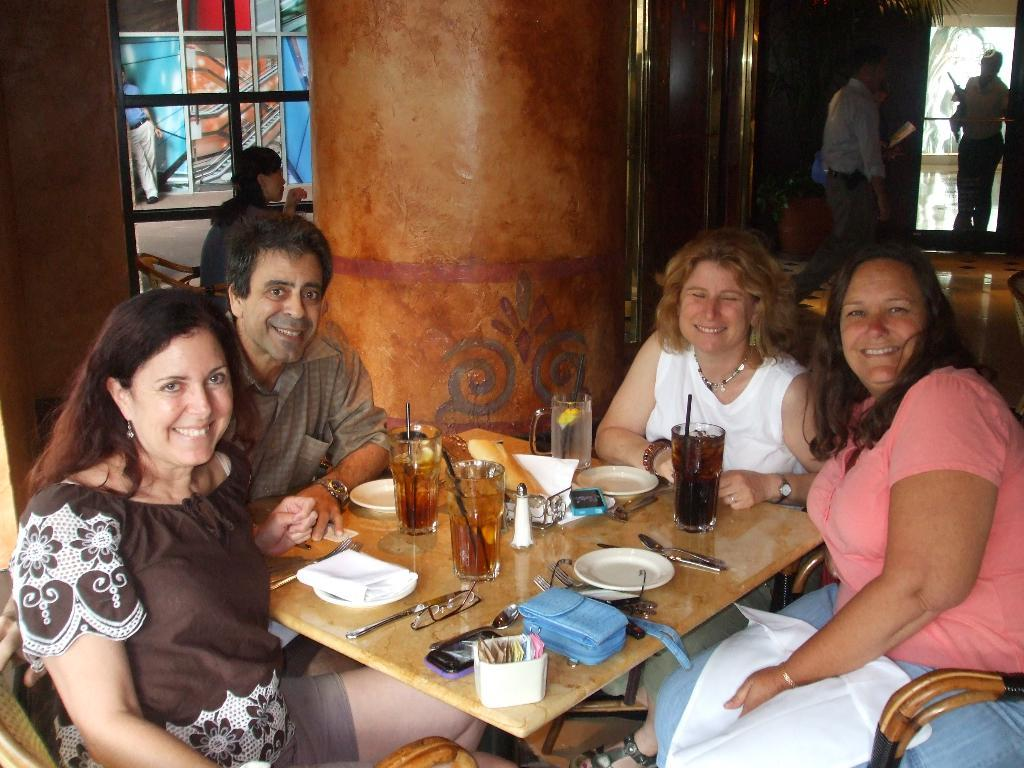How many people are in the image? There are four people in the image: three women and one man. What expressions do the people in the image have? The women and the man are all smiling. Where are the people sitting in the image? They are sitting in front of a table. What items can be seen on the table? There are plates, forks, a mobile phone, tissues, and a wine glass on the table. What type of scissors are being used by the man in the image? There are no scissors present in the image. How does the man react after sneezing in the image? There is no sneezing or reaction to it in the image. 